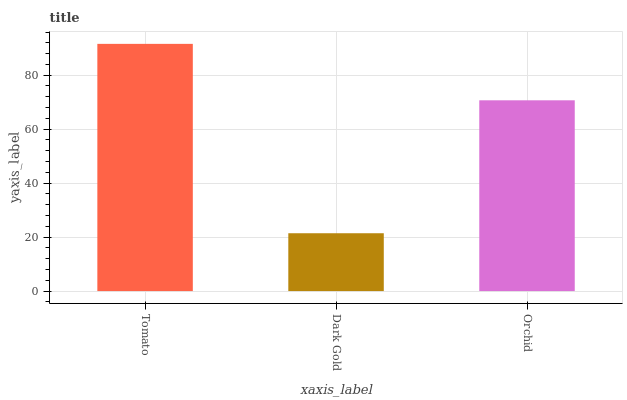Is Dark Gold the minimum?
Answer yes or no. Yes. Is Tomato the maximum?
Answer yes or no. Yes. Is Orchid the minimum?
Answer yes or no. No. Is Orchid the maximum?
Answer yes or no. No. Is Orchid greater than Dark Gold?
Answer yes or no. Yes. Is Dark Gold less than Orchid?
Answer yes or no. Yes. Is Dark Gold greater than Orchid?
Answer yes or no. No. Is Orchid less than Dark Gold?
Answer yes or no. No. Is Orchid the high median?
Answer yes or no. Yes. Is Orchid the low median?
Answer yes or no. Yes. Is Tomato the high median?
Answer yes or no. No. Is Dark Gold the low median?
Answer yes or no. No. 